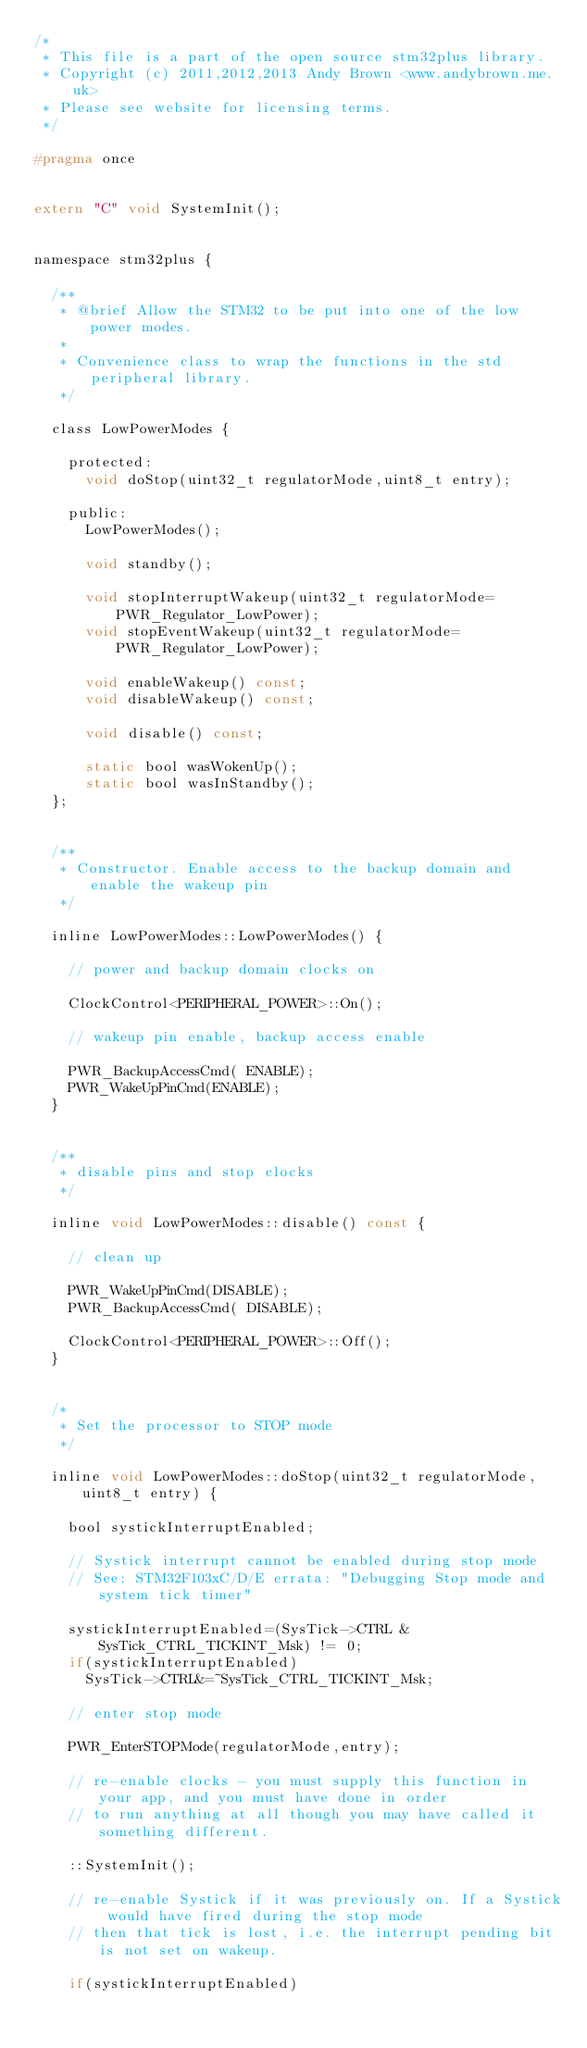Convert code to text. <code><loc_0><loc_0><loc_500><loc_500><_C_>/*
 * This file is a part of the open source stm32plus library.
 * Copyright (c) 2011,2012,2013 Andy Brown <www.andybrown.me.uk>
 * Please see website for licensing terms.
 */

#pragma once


extern "C" void SystemInit();


namespace stm32plus {

  /**
   * @brief Allow the STM32 to be put into one of the low power modes.
   *
   * Convenience class to wrap the functions in the std peripheral library.
   */

  class LowPowerModes {

    protected:
      void doStop(uint32_t regulatorMode,uint8_t entry);

    public:
      LowPowerModes();

      void standby();

      void stopInterruptWakeup(uint32_t regulatorMode=PWR_Regulator_LowPower);
      void stopEventWakeup(uint32_t regulatorMode=PWR_Regulator_LowPower);

      void enableWakeup() const;
      void disableWakeup() const;

      void disable() const;

      static bool wasWokenUp();
      static bool wasInStandby();
  };


  /**
   * Constructor. Enable access to the backup domain and enable the wakeup pin
   */

  inline LowPowerModes::LowPowerModes() {

    // power and backup domain clocks on

    ClockControl<PERIPHERAL_POWER>::On();

    // wakeup pin enable, backup access enable

    PWR_BackupAccessCmd( ENABLE);
    PWR_WakeUpPinCmd(ENABLE);
  }


  /**
   * disable pins and stop clocks
   */

  inline void LowPowerModes::disable() const {

    // clean up

    PWR_WakeUpPinCmd(DISABLE);
    PWR_BackupAccessCmd( DISABLE);

    ClockControl<PERIPHERAL_POWER>::Off();
  }


  /*
   * Set the processor to STOP mode
   */

  inline void LowPowerModes::doStop(uint32_t regulatorMode,uint8_t entry) {

    bool systickInterruptEnabled;

    // Systick interrupt cannot be enabled during stop mode
    // See: STM32F103xC/D/E errata: "Debugging Stop mode and system tick timer"

    systickInterruptEnabled=(SysTick->CTRL & SysTick_CTRL_TICKINT_Msk) != 0;
    if(systickInterruptEnabled)
      SysTick->CTRL&=~SysTick_CTRL_TICKINT_Msk;

    // enter stop mode

    PWR_EnterSTOPMode(regulatorMode,entry);

    // re-enable clocks - you must supply this function in your app, and you must have done in order
    // to run anything at all though you may have called it something different.

    ::SystemInit();

    // re-enable Systick if it was previously on. If a Systick would have fired during the stop mode
    // then that tick is lost, i.e. the interrupt pending bit is not set on wakeup.

    if(systickInterruptEnabled)</code> 